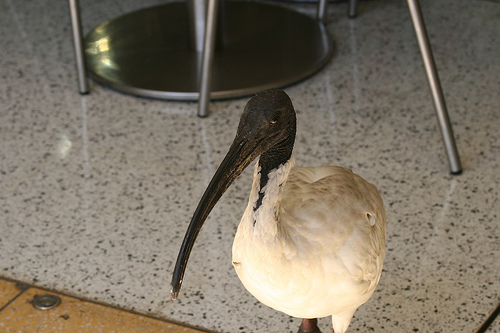Describe the surroundings of this bird. The bird is inside a building, as indicated by the tiled floor and the metal legs of furniture in the background, likely a cafe or a similar establishment. How can you tell it's an ibis and not another bird? The ibis has several distinctive features, such as a long, narrow, and curved beak used for probing into the soil for food, and a rounded body. This particular ibis has white plumage, which, depending on the species, could indicate it’s a sacred ibis or an Australian white ibis. 